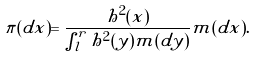<formula> <loc_0><loc_0><loc_500><loc_500>\pi ( d x ) = \frac { h ^ { 2 } ( x ) } { \int _ { l } ^ { r } h ^ { 2 } ( y ) m ( d y ) } m ( d x ) .</formula> 